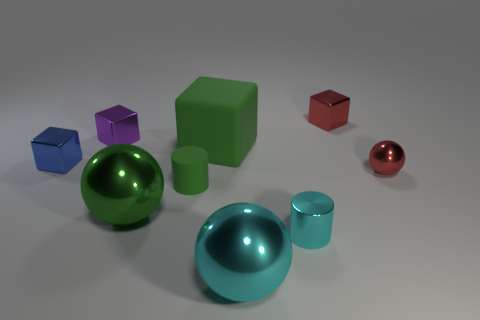Subtract all rubber cubes. How many cubes are left? 3 Subtract all blue blocks. How many blocks are left? 3 Subtract 2 cubes. How many cubes are left? 2 Subtract all gray cubes. Subtract all yellow spheres. How many cubes are left? 4 Add 1 tiny red balls. How many objects exist? 10 Subtract all blocks. How many objects are left? 5 Add 4 tiny brown matte cylinders. How many tiny brown matte cylinders exist? 4 Subtract 1 red blocks. How many objects are left? 8 Subtract all shiny balls. Subtract all large matte things. How many objects are left? 5 Add 9 purple shiny cubes. How many purple shiny cubes are left? 10 